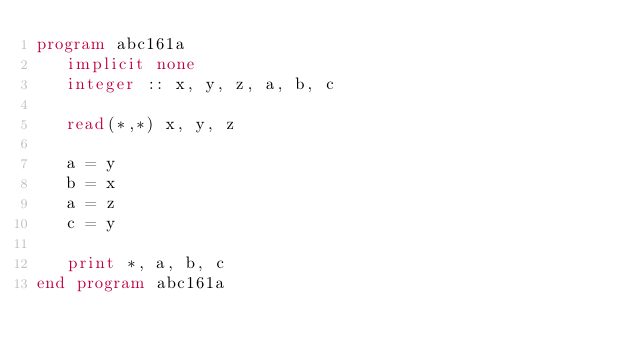<code> <loc_0><loc_0><loc_500><loc_500><_FORTRAN_>program abc161a
   implicit none
   integer :: x, y, z, a, b, c

   read(*,*) x, y, z

   a = y
   b = x
   a = z
   c = y

   print *, a, b, c
end program abc161a   
</code> 